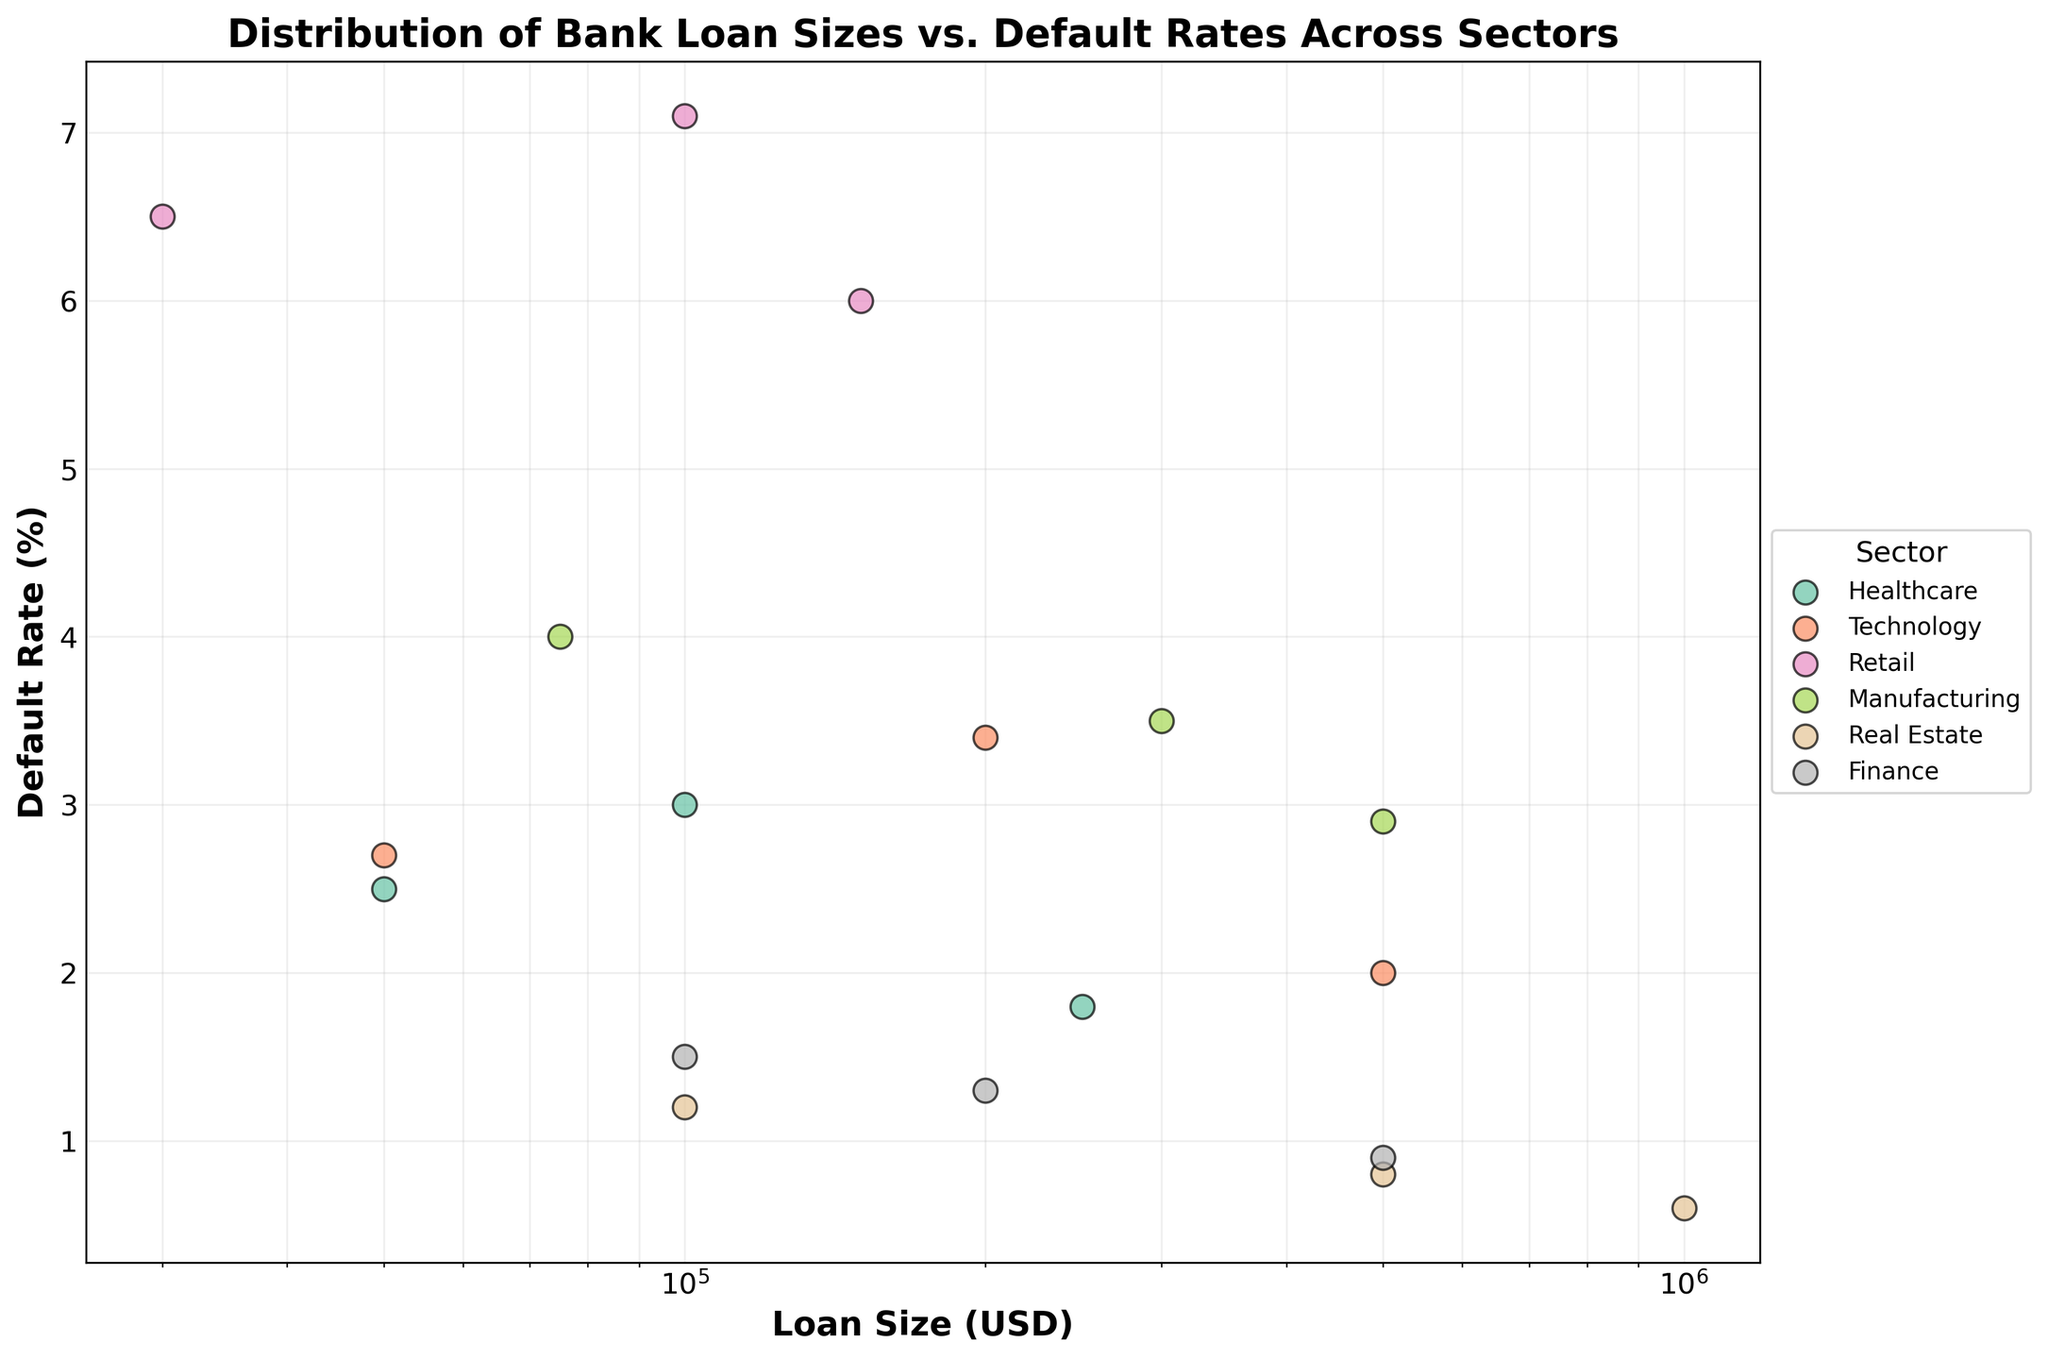what is the title of the plot? The title of the plot is usually displayed at the top of the figure. In this case, it reads "Distribution of Bank Loan Sizes vs. Default Rates Across Sectors."
Answer: Distribution of Bank Loan Sizes vs. Default Rates Across Sectors What is the default rate for the largest loan size in the finance sector? First, locate the finance sector in the legend. The largest loan size for finance is 500,000 USD, and the corresponding default rate is 0.9%.
Answer: 0.9% Which sector has the lowest default rate for loans of 100,000 USD? Look at the x-axis for loans of 100,000 USD and observe the default rates for each sector. Real Estate has the lowest default rate at this loan size, which is 1.2%.
Answer: Real Estate How many data points are there in total for the Retail sector? Count the number of distinct data points (scatter markers) in the Retail sector by checking the appropriate color and markers. There are 3 data points in the Retail sector.
Answer: 3 Which sector has the highest default rate, and what is this rate? Scan through the points on the plot to find the maximum default rate value. Retail has the highest default rate, which is 7.1%.
Answer: Retail, 7.1% Between technology and manufacturing for a loan size of 500,000 USD, which has the lower default rate? Locate the loan size of 500,000 USD on the x-axis. Compare the default rates for technology and manufacturing. Technology has a 2.0% default rate, and manufacturing has a 2.9% default rate, so technology is lower.
Answer: Technology What is the range of default rates for the Technology sector? Identify the highest and lowest default rates for the Technology sector: 3.4% (highest) and 2.0% (lowest). Calculate the difference: 3.4 - 2.0 = 1.4%.
Answer: 1.4% Which sector has the widest spread of default rates? By visually comparing the spread (difference between the highest and lowest values) of default rates for all sectors, Retail has the widest spread from 6.0% to 7.1%, which is 1.1%.
Answer: Retail What is the median default rate for loans in the Manufacturing sector? List the default rates for Manufacturing sector loans: 4.0%, 3.5%, 2.9%. The median (middle) value in this sorted list is 3.5%.
Answer: 3.5% Are default rates generally higher for smaller or larger loans in the Real Estate sector? Compare the default rates for different loan sizes within the Real Estate sector: 100,000 USD (1.2%), 500,000 USD (0.8%), 1,000,000 USD (0.6%). Smaller loans have higher default rates compared to larger loans.
Answer: Smaller loans 